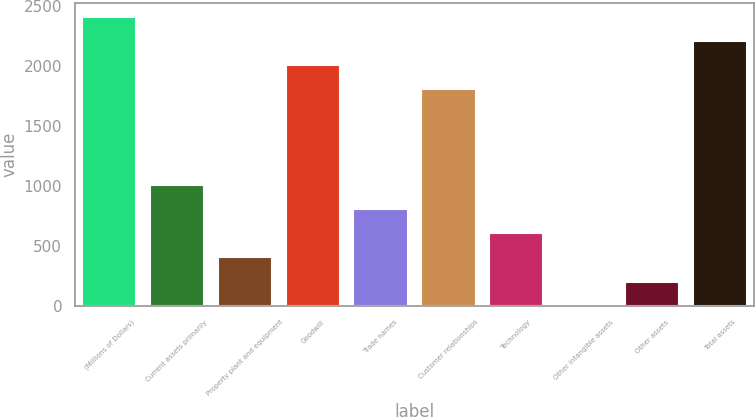Convert chart to OTSL. <chart><loc_0><loc_0><loc_500><loc_500><bar_chart><fcel>(Millions of Dollars)<fcel>Current assets primarily<fcel>Property plant and equipment<fcel>Goodwill<fcel>Trade names<fcel>Customer relationships<fcel>Technology<fcel>Other intangible assets<fcel>Other assets<fcel>Total assets<nl><fcel>2409.4<fcel>1004.5<fcel>402.4<fcel>2008<fcel>803.8<fcel>1807.3<fcel>603.1<fcel>1<fcel>201.7<fcel>2208.7<nl></chart> 